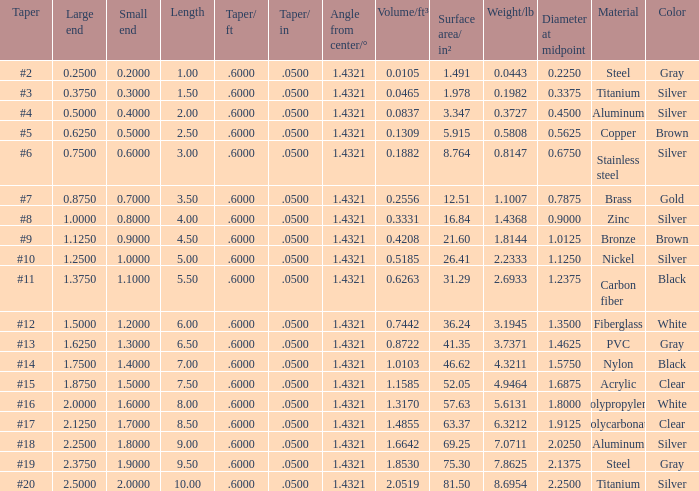Which Large end has a Taper/ft smaller than 0.6000000000000001? 19.0. 